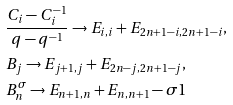<formula> <loc_0><loc_0><loc_500><loc_500>& \frac { C _ { i } - C _ { i } ^ { - 1 } } { q - q ^ { - 1 } } \rightarrow E _ { i , i } + E _ { 2 n + 1 - i , 2 n + 1 - i } , \\ & B _ { j } \rightarrow E _ { j + 1 , j } + E _ { 2 n - j , 2 n + 1 - j } , \\ & B _ { n } ^ { \sigma } \rightarrow E _ { n + 1 , n } + E _ { n , n + 1 } - \sigma 1</formula> 